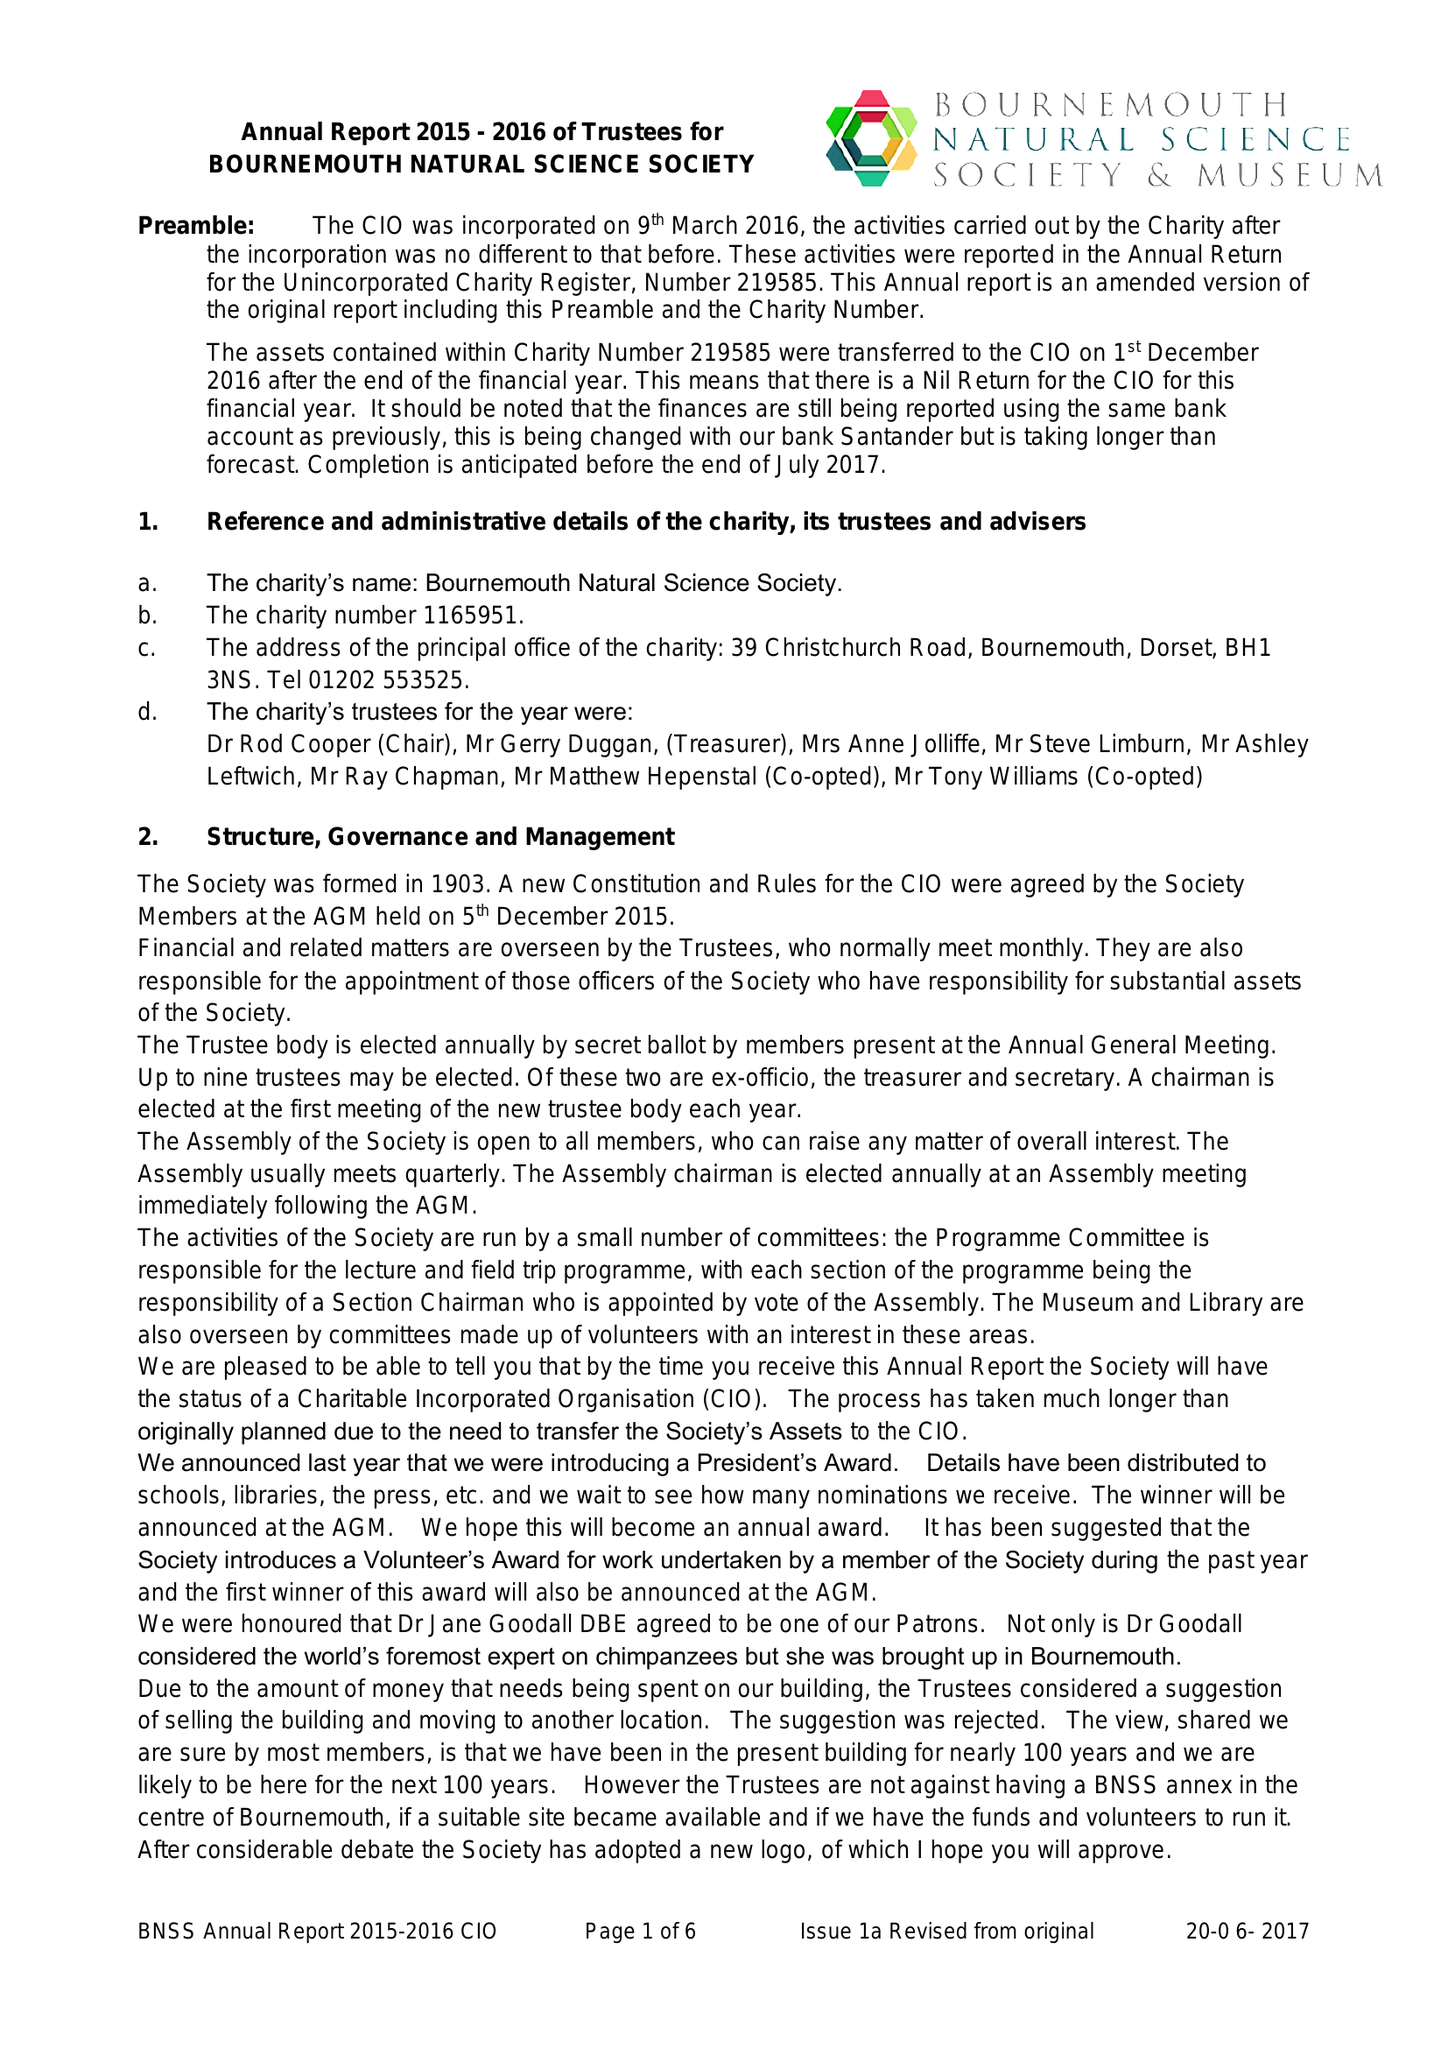What is the value for the report_date?
Answer the question using a single word or phrase. 2016-09-30 